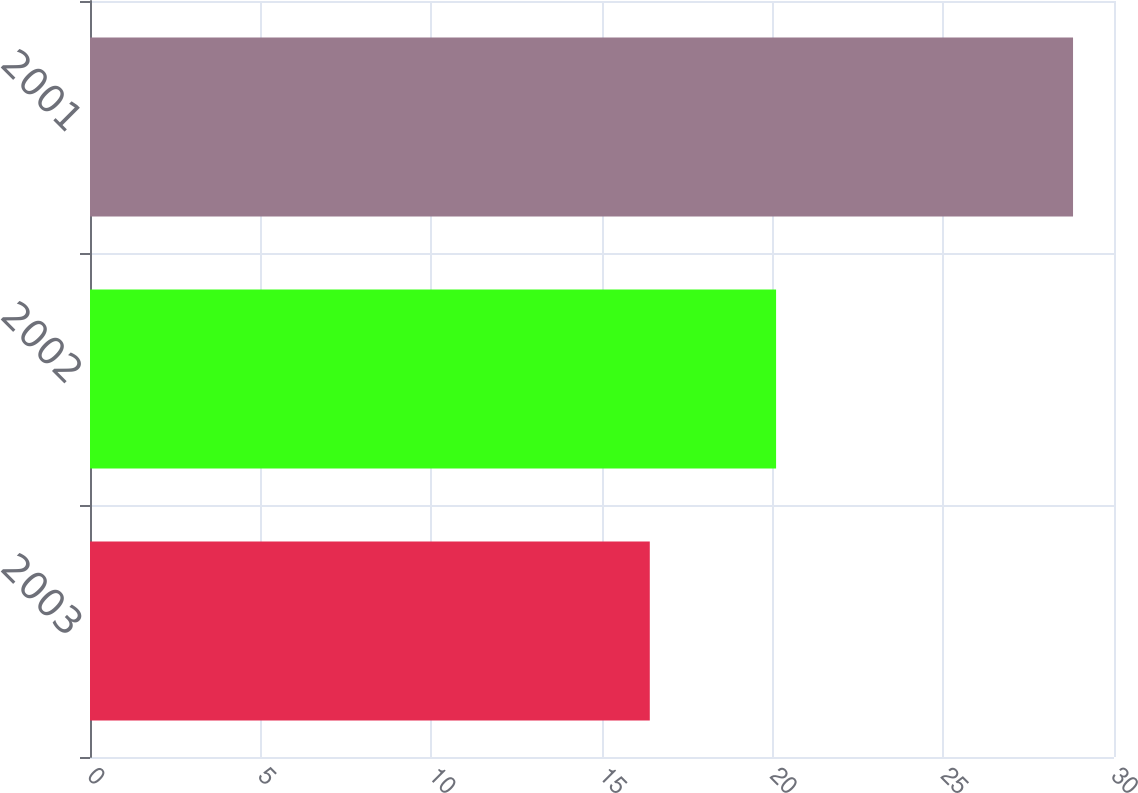Convert chart. <chart><loc_0><loc_0><loc_500><loc_500><bar_chart><fcel>2003<fcel>2002<fcel>2001<nl><fcel>16.4<fcel>20.1<fcel>28.8<nl></chart> 